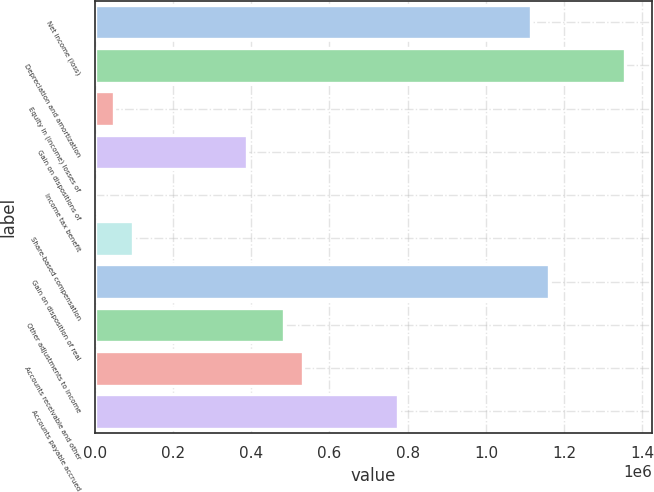Convert chart to OTSL. <chart><loc_0><loc_0><loc_500><loc_500><bar_chart><fcel>Net income (loss)<fcel>Depreciation and amortization<fcel>Equity in (income) losses of<fcel>Gain on dispositions of<fcel>Income tax benefit<fcel>Share-based compensation<fcel>Gain on disposition of real<fcel>Other adjustments to income<fcel>Accounts receivable and other<fcel>Accounts payable accrued<nl><fcel>1.11416e+06<fcel>1.35619e+06<fcel>49262.6<fcel>388095<fcel>858<fcel>97667.2<fcel>1.16257e+06<fcel>484904<fcel>533309<fcel>775332<nl></chart> 